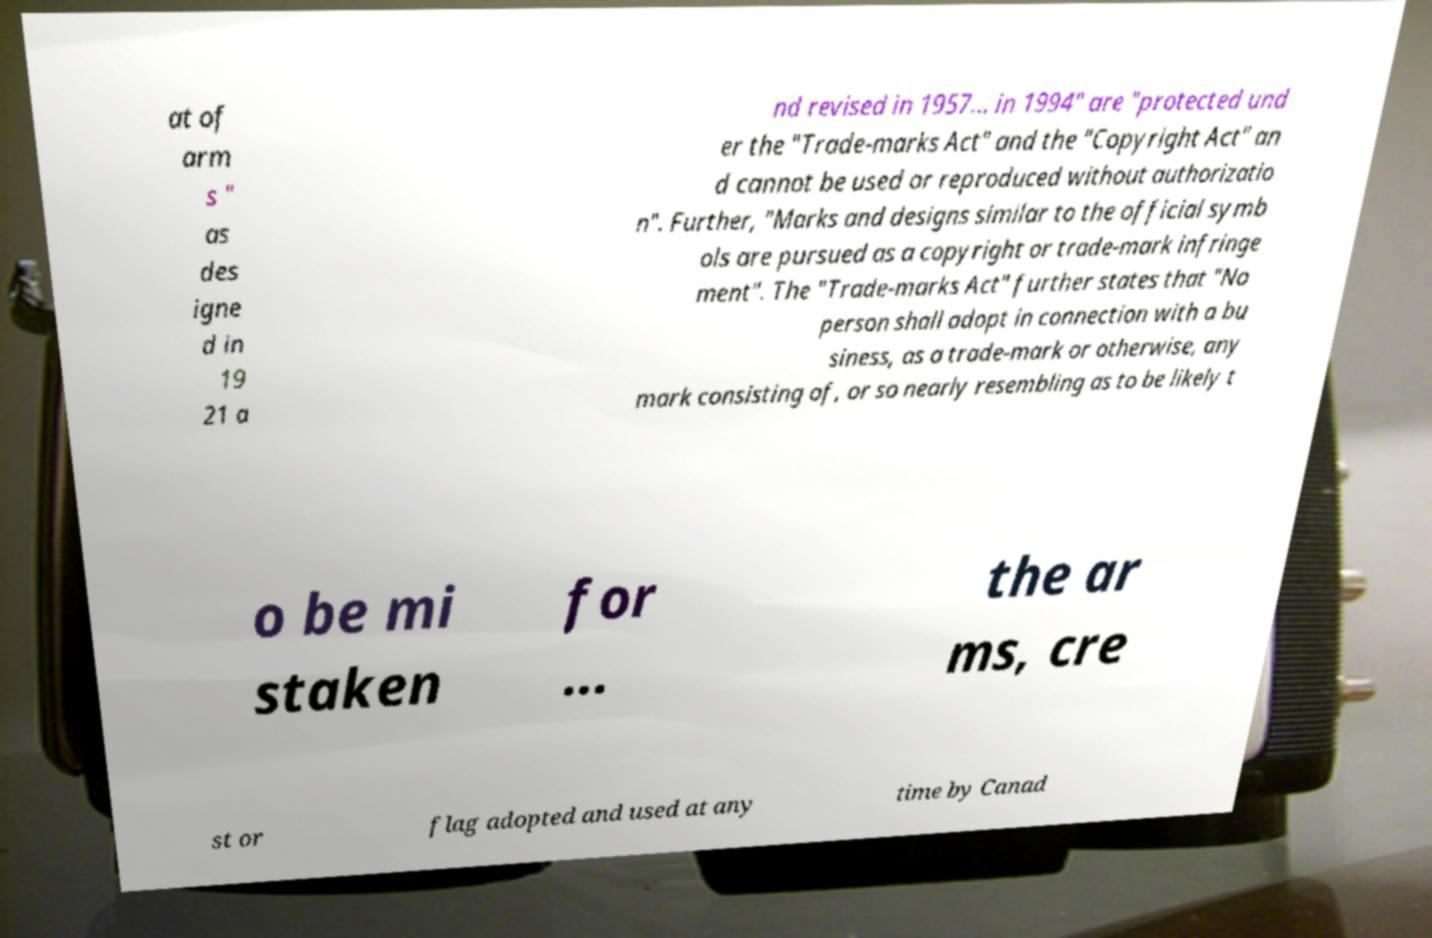Could you assist in decoding the text presented in this image and type it out clearly? at of arm s " as des igne d in 19 21 a nd revised in 1957... in 1994" are "protected und er the "Trade-marks Act" and the "Copyright Act" an d cannot be used or reproduced without authorizatio n". Further, "Marks and designs similar to the official symb ols are pursued as a copyright or trade-mark infringe ment". The "Trade-marks Act" further states that "No person shall adopt in connection with a bu siness, as a trade-mark or otherwise, any mark consisting of, or so nearly resembling as to be likely t o be mi staken for ... the ar ms, cre st or flag adopted and used at any time by Canad 